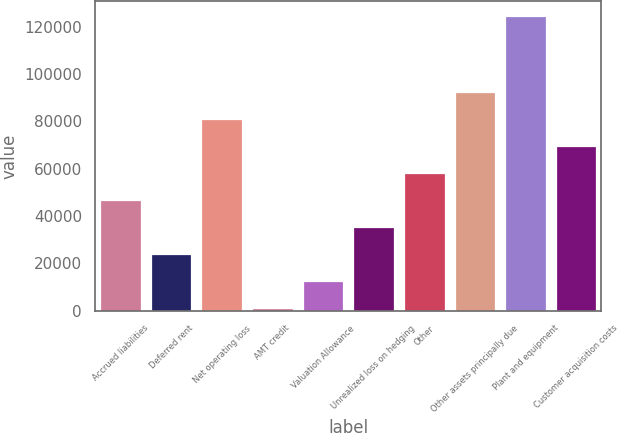<chart> <loc_0><loc_0><loc_500><loc_500><bar_chart><fcel>Accrued liabilities<fcel>Deferred rent<fcel>Net operating loss<fcel>AMT credit<fcel>Valuation Allowance<fcel>Unrealized loss on hedging<fcel>Other<fcel>Other assets principally due<fcel>Plant and equipment<fcel>Customer acquisition costs<nl><fcel>46736.6<fcel>23961.8<fcel>80898.8<fcel>1187<fcel>12574.4<fcel>35349.2<fcel>58124<fcel>92286.2<fcel>124575<fcel>69511.4<nl></chart> 